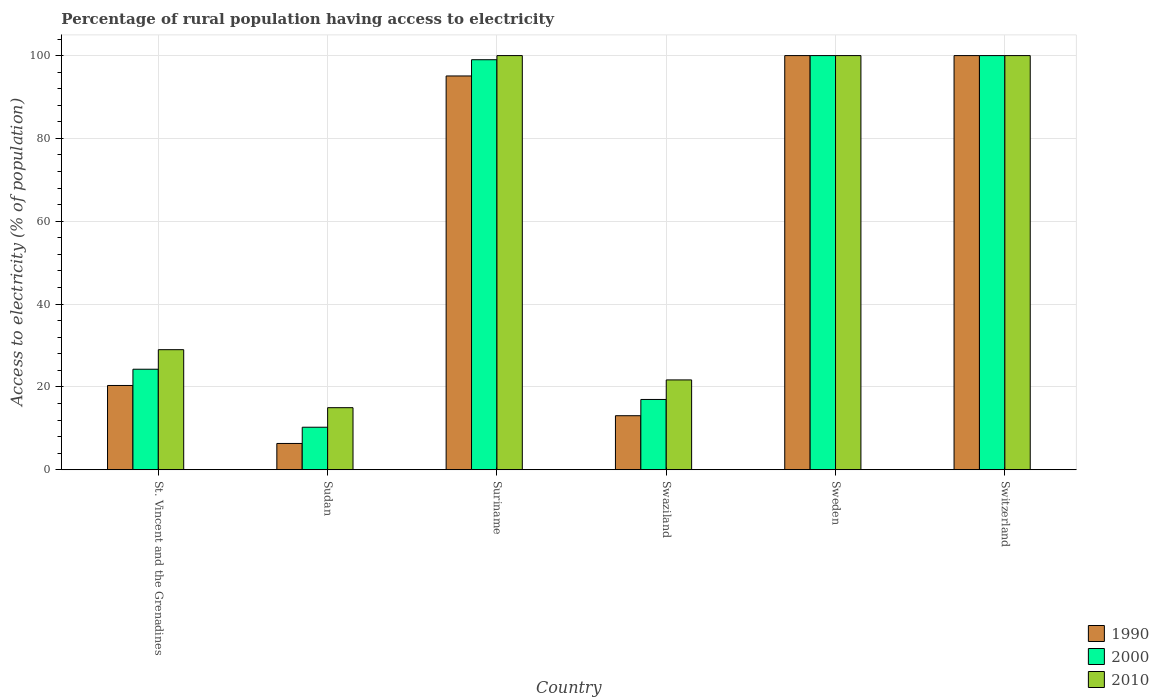How many groups of bars are there?
Offer a very short reply. 6. Are the number of bars per tick equal to the number of legend labels?
Ensure brevity in your answer.  Yes. How many bars are there on the 4th tick from the left?
Keep it short and to the point. 3. What is the label of the 1st group of bars from the left?
Offer a very short reply. St. Vincent and the Grenadines. What is the percentage of rural population having access to electricity in 2000 in Swaziland?
Your response must be concise. 16.98. In which country was the percentage of rural population having access to electricity in 2010 maximum?
Offer a very short reply. Suriname. In which country was the percentage of rural population having access to electricity in 1990 minimum?
Provide a succinct answer. Sudan. What is the total percentage of rural population having access to electricity in 2000 in the graph?
Offer a terse response. 350.54. What is the difference between the percentage of rural population having access to electricity in 1990 in Suriname and that in Swaziland?
Ensure brevity in your answer.  82.02. What is the average percentage of rural population having access to electricity in 1990 per country?
Offer a terse response. 55.81. What is the difference between the percentage of rural population having access to electricity of/in 1990 and percentage of rural population having access to electricity of/in 2010 in Sudan?
Provide a short and direct response. -8.64. In how many countries, is the percentage of rural population having access to electricity in 1990 greater than 4 %?
Ensure brevity in your answer.  6. What is the ratio of the percentage of rural population having access to electricity in 2000 in St. Vincent and the Grenadines to that in Switzerland?
Your answer should be very brief. 0.24. Is the percentage of rural population having access to electricity in 2010 in Swaziland less than that in Sweden?
Offer a terse response. Yes. Is the difference between the percentage of rural population having access to electricity in 1990 in Suriname and Swaziland greater than the difference between the percentage of rural population having access to electricity in 2010 in Suriname and Swaziland?
Your answer should be very brief. Yes. What is the difference between the highest and the lowest percentage of rural population having access to electricity in 2010?
Your answer should be compact. 85. Is the sum of the percentage of rural population having access to electricity in 1990 in Suriname and Swaziland greater than the maximum percentage of rural population having access to electricity in 2000 across all countries?
Give a very brief answer. Yes. What does the 1st bar from the right in St. Vincent and the Grenadines represents?
Your answer should be compact. 2010. How many bars are there?
Provide a short and direct response. 18. Are all the bars in the graph horizontal?
Make the answer very short. No. How many countries are there in the graph?
Ensure brevity in your answer.  6. Are the values on the major ticks of Y-axis written in scientific E-notation?
Make the answer very short. No. Does the graph contain any zero values?
Keep it short and to the point. No. Does the graph contain grids?
Your answer should be very brief. Yes. Where does the legend appear in the graph?
Provide a succinct answer. Bottom right. How are the legend labels stacked?
Keep it short and to the point. Vertical. What is the title of the graph?
Provide a short and direct response. Percentage of rural population having access to electricity. Does "1977" appear as one of the legend labels in the graph?
Keep it short and to the point. No. What is the label or title of the Y-axis?
Your answer should be very brief. Access to electricity (% of population). What is the Access to electricity (% of population) in 1990 in St. Vincent and the Grenadines?
Provide a succinct answer. 20.36. What is the Access to electricity (% of population) of 2000 in St. Vincent and the Grenadines?
Ensure brevity in your answer.  24.28. What is the Access to electricity (% of population) in 1990 in Sudan?
Keep it short and to the point. 6.36. What is the Access to electricity (% of population) in 2000 in Sudan?
Ensure brevity in your answer.  10.28. What is the Access to electricity (% of population) of 1990 in Suriname?
Keep it short and to the point. 95.08. What is the Access to electricity (% of population) of 2000 in Suriname?
Keep it short and to the point. 99. What is the Access to electricity (% of population) in 1990 in Swaziland?
Offer a very short reply. 13.06. What is the Access to electricity (% of population) in 2000 in Swaziland?
Ensure brevity in your answer.  16.98. What is the Access to electricity (% of population) in 2010 in Swaziland?
Offer a terse response. 21.7. What is the Access to electricity (% of population) in 2000 in Sweden?
Your answer should be very brief. 100. What is the Access to electricity (% of population) of 1990 in Switzerland?
Your answer should be compact. 100. Across all countries, what is the maximum Access to electricity (% of population) in 2000?
Ensure brevity in your answer.  100. Across all countries, what is the maximum Access to electricity (% of population) in 2010?
Provide a succinct answer. 100. Across all countries, what is the minimum Access to electricity (% of population) of 1990?
Offer a very short reply. 6.36. Across all countries, what is the minimum Access to electricity (% of population) of 2000?
Keep it short and to the point. 10.28. What is the total Access to electricity (% of population) in 1990 in the graph?
Your answer should be very brief. 334.86. What is the total Access to electricity (% of population) of 2000 in the graph?
Your answer should be very brief. 350.54. What is the total Access to electricity (% of population) in 2010 in the graph?
Your response must be concise. 365.7. What is the difference between the Access to electricity (% of population) of 2010 in St. Vincent and the Grenadines and that in Sudan?
Provide a short and direct response. 14. What is the difference between the Access to electricity (% of population) of 1990 in St. Vincent and the Grenadines and that in Suriname?
Provide a short and direct response. -74.72. What is the difference between the Access to electricity (% of population) in 2000 in St. Vincent and the Grenadines and that in Suriname?
Offer a very short reply. -74.72. What is the difference between the Access to electricity (% of population) in 2010 in St. Vincent and the Grenadines and that in Suriname?
Provide a short and direct response. -71. What is the difference between the Access to electricity (% of population) of 2010 in St. Vincent and the Grenadines and that in Swaziland?
Your answer should be very brief. 7.3. What is the difference between the Access to electricity (% of population) of 1990 in St. Vincent and the Grenadines and that in Sweden?
Your answer should be compact. -79.64. What is the difference between the Access to electricity (% of population) in 2000 in St. Vincent and the Grenadines and that in Sweden?
Your response must be concise. -75.72. What is the difference between the Access to electricity (% of population) in 2010 in St. Vincent and the Grenadines and that in Sweden?
Your answer should be compact. -71. What is the difference between the Access to electricity (% of population) in 1990 in St. Vincent and the Grenadines and that in Switzerland?
Your answer should be compact. -79.64. What is the difference between the Access to electricity (% of population) in 2000 in St. Vincent and the Grenadines and that in Switzerland?
Offer a terse response. -75.72. What is the difference between the Access to electricity (% of population) of 2010 in St. Vincent and the Grenadines and that in Switzerland?
Provide a succinct answer. -71. What is the difference between the Access to electricity (% of population) in 1990 in Sudan and that in Suriname?
Offer a terse response. -88.72. What is the difference between the Access to electricity (% of population) of 2000 in Sudan and that in Suriname?
Provide a short and direct response. -88.72. What is the difference between the Access to electricity (% of population) in 2010 in Sudan and that in Suriname?
Make the answer very short. -85. What is the difference between the Access to electricity (% of population) of 1990 in Sudan and that in Swaziland?
Give a very brief answer. -6.7. What is the difference between the Access to electricity (% of population) in 2000 in Sudan and that in Swaziland?
Ensure brevity in your answer.  -6.7. What is the difference between the Access to electricity (% of population) in 1990 in Sudan and that in Sweden?
Give a very brief answer. -93.64. What is the difference between the Access to electricity (% of population) in 2000 in Sudan and that in Sweden?
Provide a succinct answer. -89.72. What is the difference between the Access to electricity (% of population) of 2010 in Sudan and that in Sweden?
Make the answer very short. -85. What is the difference between the Access to electricity (% of population) of 1990 in Sudan and that in Switzerland?
Keep it short and to the point. -93.64. What is the difference between the Access to electricity (% of population) of 2000 in Sudan and that in Switzerland?
Provide a short and direct response. -89.72. What is the difference between the Access to electricity (% of population) in 2010 in Sudan and that in Switzerland?
Your response must be concise. -85. What is the difference between the Access to electricity (% of population) in 1990 in Suriname and that in Swaziland?
Offer a terse response. 82.02. What is the difference between the Access to electricity (% of population) of 2000 in Suriname and that in Swaziland?
Make the answer very short. 82.02. What is the difference between the Access to electricity (% of population) in 2010 in Suriname and that in Swaziland?
Your response must be concise. 78.3. What is the difference between the Access to electricity (% of population) in 1990 in Suriname and that in Sweden?
Your answer should be very brief. -4.92. What is the difference between the Access to electricity (% of population) in 1990 in Suriname and that in Switzerland?
Offer a terse response. -4.92. What is the difference between the Access to electricity (% of population) of 1990 in Swaziland and that in Sweden?
Ensure brevity in your answer.  -86.94. What is the difference between the Access to electricity (% of population) in 2000 in Swaziland and that in Sweden?
Make the answer very short. -83.02. What is the difference between the Access to electricity (% of population) in 2010 in Swaziland and that in Sweden?
Ensure brevity in your answer.  -78.3. What is the difference between the Access to electricity (% of population) in 1990 in Swaziland and that in Switzerland?
Provide a succinct answer. -86.94. What is the difference between the Access to electricity (% of population) in 2000 in Swaziland and that in Switzerland?
Give a very brief answer. -83.02. What is the difference between the Access to electricity (% of population) of 2010 in Swaziland and that in Switzerland?
Your answer should be compact. -78.3. What is the difference between the Access to electricity (% of population) of 1990 in St. Vincent and the Grenadines and the Access to electricity (% of population) of 2000 in Sudan?
Provide a short and direct response. 10.08. What is the difference between the Access to electricity (% of population) of 1990 in St. Vincent and the Grenadines and the Access to electricity (% of population) of 2010 in Sudan?
Ensure brevity in your answer.  5.36. What is the difference between the Access to electricity (% of population) in 2000 in St. Vincent and the Grenadines and the Access to electricity (% of population) in 2010 in Sudan?
Offer a terse response. 9.28. What is the difference between the Access to electricity (% of population) of 1990 in St. Vincent and the Grenadines and the Access to electricity (% of population) of 2000 in Suriname?
Your response must be concise. -78.64. What is the difference between the Access to electricity (% of population) in 1990 in St. Vincent and the Grenadines and the Access to electricity (% of population) in 2010 in Suriname?
Keep it short and to the point. -79.64. What is the difference between the Access to electricity (% of population) of 2000 in St. Vincent and the Grenadines and the Access to electricity (% of population) of 2010 in Suriname?
Give a very brief answer. -75.72. What is the difference between the Access to electricity (% of population) of 1990 in St. Vincent and the Grenadines and the Access to electricity (% of population) of 2000 in Swaziland?
Make the answer very short. 3.38. What is the difference between the Access to electricity (% of population) in 1990 in St. Vincent and the Grenadines and the Access to electricity (% of population) in 2010 in Swaziland?
Provide a short and direct response. -1.34. What is the difference between the Access to electricity (% of population) in 2000 in St. Vincent and the Grenadines and the Access to electricity (% of population) in 2010 in Swaziland?
Offer a terse response. 2.58. What is the difference between the Access to electricity (% of population) in 1990 in St. Vincent and the Grenadines and the Access to electricity (% of population) in 2000 in Sweden?
Offer a terse response. -79.64. What is the difference between the Access to electricity (% of population) in 1990 in St. Vincent and the Grenadines and the Access to electricity (% of population) in 2010 in Sweden?
Give a very brief answer. -79.64. What is the difference between the Access to electricity (% of population) of 2000 in St. Vincent and the Grenadines and the Access to electricity (% of population) of 2010 in Sweden?
Give a very brief answer. -75.72. What is the difference between the Access to electricity (% of population) of 1990 in St. Vincent and the Grenadines and the Access to electricity (% of population) of 2000 in Switzerland?
Give a very brief answer. -79.64. What is the difference between the Access to electricity (% of population) of 1990 in St. Vincent and the Grenadines and the Access to electricity (% of population) of 2010 in Switzerland?
Keep it short and to the point. -79.64. What is the difference between the Access to electricity (% of population) in 2000 in St. Vincent and the Grenadines and the Access to electricity (% of population) in 2010 in Switzerland?
Your answer should be compact. -75.72. What is the difference between the Access to electricity (% of population) in 1990 in Sudan and the Access to electricity (% of population) in 2000 in Suriname?
Provide a succinct answer. -92.64. What is the difference between the Access to electricity (% of population) in 1990 in Sudan and the Access to electricity (% of population) in 2010 in Suriname?
Keep it short and to the point. -93.64. What is the difference between the Access to electricity (% of population) in 2000 in Sudan and the Access to electricity (% of population) in 2010 in Suriname?
Keep it short and to the point. -89.72. What is the difference between the Access to electricity (% of population) of 1990 in Sudan and the Access to electricity (% of population) of 2000 in Swaziland?
Offer a very short reply. -10.62. What is the difference between the Access to electricity (% of population) of 1990 in Sudan and the Access to electricity (% of population) of 2010 in Swaziland?
Ensure brevity in your answer.  -15.34. What is the difference between the Access to electricity (% of population) in 2000 in Sudan and the Access to electricity (% of population) in 2010 in Swaziland?
Offer a terse response. -11.42. What is the difference between the Access to electricity (% of population) in 1990 in Sudan and the Access to electricity (% of population) in 2000 in Sweden?
Your response must be concise. -93.64. What is the difference between the Access to electricity (% of population) in 1990 in Sudan and the Access to electricity (% of population) in 2010 in Sweden?
Provide a succinct answer. -93.64. What is the difference between the Access to electricity (% of population) in 2000 in Sudan and the Access to electricity (% of population) in 2010 in Sweden?
Your response must be concise. -89.72. What is the difference between the Access to electricity (% of population) in 1990 in Sudan and the Access to electricity (% of population) in 2000 in Switzerland?
Provide a succinct answer. -93.64. What is the difference between the Access to electricity (% of population) of 1990 in Sudan and the Access to electricity (% of population) of 2010 in Switzerland?
Your response must be concise. -93.64. What is the difference between the Access to electricity (% of population) in 2000 in Sudan and the Access to electricity (% of population) in 2010 in Switzerland?
Your answer should be very brief. -89.72. What is the difference between the Access to electricity (% of population) of 1990 in Suriname and the Access to electricity (% of population) of 2000 in Swaziland?
Your answer should be compact. 78.1. What is the difference between the Access to electricity (% of population) in 1990 in Suriname and the Access to electricity (% of population) in 2010 in Swaziland?
Provide a succinct answer. 73.38. What is the difference between the Access to electricity (% of population) in 2000 in Suriname and the Access to electricity (% of population) in 2010 in Swaziland?
Make the answer very short. 77.3. What is the difference between the Access to electricity (% of population) in 1990 in Suriname and the Access to electricity (% of population) in 2000 in Sweden?
Your answer should be compact. -4.92. What is the difference between the Access to electricity (% of population) of 1990 in Suriname and the Access to electricity (% of population) of 2010 in Sweden?
Give a very brief answer. -4.92. What is the difference between the Access to electricity (% of population) in 2000 in Suriname and the Access to electricity (% of population) in 2010 in Sweden?
Make the answer very short. -1. What is the difference between the Access to electricity (% of population) of 1990 in Suriname and the Access to electricity (% of population) of 2000 in Switzerland?
Provide a succinct answer. -4.92. What is the difference between the Access to electricity (% of population) of 1990 in Suriname and the Access to electricity (% of population) of 2010 in Switzerland?
Provide a succinct answer. -4.92. What is the difference between the Access to electricity (% of population) in 2000 in Suriname and the Access to electricity (% of population) in 2010 in Switzerland?
Your answer should be compact. -1. What is the difference between the Access to electricity (% of population) of 1990 in Swaziland and the Access to electricity (% of population) of 2000 in Sweden?
Your answer should be very brief. -86.94. What is the difference between the Access to electricity (% of population) in 1990 in Swaziland and the Access to electricity (% of population) in 2010 in Sweden?
Ensure brevity in your answer.  -86.94. What is the difference between the Access to electricity (% of population) in 2000 in Swaziland and the Access to electricity (% of population) in 2010 in Sweden?
Give a very brief answer. -83.02. What is the difference between the Access to electricity (% of population) of 1990 in Swaziland and the Access to electricity (% of population) of 2000 in Switzerland?
Your answer should be very brief. -86.94. What is the difference between the Access to electricity (% of population) of 1990 in Swaziland and the Access to electricity (% of population) of 2010 in Switzerland?
Your response must be concise. -86.94. What is the difference between the Access to electricity (% of population) of 2000 in Swaziland and the Access to electricity (% of population) of 2010 in Switzerland?
Ensure brevity in your answer.  -83.02. What is the difference between the Access to electricity (% of population) of 1990 in Sweden and the Access to electricity (% of population) of 2000 in Switzerland?
Make the answer very short. 0. What is the difference between the Access to electricity (% of population) in 1990 in Sweden and the Access to electricity (% of population) in 2010 in Switzerland?
Your answer should be compact. 0. What is the average Access to electricity (% of population) of 1990 per country?
Offer a very short reply. 55.81. What is the average Access to electricity (% of population) in 2000 per country?
Your response must be concise. 58.42. What is the average Access to electricity (% of population) in 2010 per country?
Your answer should be compact. 60.95. What is the difference between the Access to electricity (% of population) in 1990 and Access to electricity (% of population) in 2000 in St. Vincent and the Grenadines?
Provide a succinct answer. -3.92. What is the difference between the Access to electricity (% of population) of 1990 and Access to electricity (% of population) of 2010 in St. Vincent and the Grenadines?
Offer a very short reply. -8.64. What is the difference between the Access to electricity (% of population) of 2000 and Access to electricity (% of population) of 2010 in St. Vincent and the Grenadines?
Your answer should be very brief. -4.72. What is the difference between the Access to electricity (% of population) of 1990 and Access to electricity (% of population) of 2000 in Sudan?
Your response must be concise. -3.92. What is the difference between the Access to electricity (% of population) in 1990 and Access to electricity (% of population) in 2010 in Sudan?
Keep it short and to the point. -8.64. What is the difference between the Access to electricity (% of population) in 2000 and Access to electricity (% of population) in 2010 in Sudan?
Offer a terse response. -4.72. What is the difference between the Access to electricity (% of population) in 1990 and Access to electricity (% of population) in 2000 in Suriname?
Ensure brevity in your answer.  -3.92. What is the difference between the Access to electricity (% of population) in 1990 and Access to electricity (% of population) in 2010 in Suriname?
Give a very brief answer. -4.92. What is the difference between the Access to electricity (% of population) in 2000 and Access to electricity (% of population) in 2010 in Suriname?
Keep it short and to the point. -1. What is the difference between the Access to electricity (% of population) in 1990 and Access to electricity (% of population) in 2000 in Swaziland?
Provide a succinct answer. -3.92. What is the difference between the Access to electricity (% of population) in 1990 and Access to electricity (% of population) in 2010 in Swaziland?
Your answer should be compact. -8.64. What is the difference between the Access to electricity (% of population) of 2000 and Access to electricity (% of population) of 2010 in Swaziland?
Your answer should be compact. -4.72. What is the difference between the Access to electricity (% of population) of 1990 and Access to electricity (% of population) of 2010 in Sweden?
Ensure brevity in your answer.  0. What is the difference between the Access to electricity (% of population) in 2000 and Access to electricity (% of population) in 2010 in Sweden?
Provide a succinct answer. 0. What is the difference between the Access to electricity (% of population) in 1990 and Access to electricity (% of population) in 2000 in Switzerland?
Your response must be concise. 0. What is the ratio of the Access to electricity (% of population) in 1990 in St. Vincent and the Grenadines to that in Sudan?
Ensure brevity in your answer.  3.2. What is the ratio of the Access to electricity (% of population) in 2000 in St. Vincent and the Grenadines to that in Sudan?
Provide a succinct answer. 2.36. What is the ratio of the Access to electricity (% of population) of 2010 in St. Vincent and the Grenadines to that in Sudan?
Ensure brevity in your answer.  1.93. What is the ratio of the Access to electricity (% of population) of 1990 in St. Vincent and the Grenadines to that in Suriname?
Provide a succinct answer. 0.21. What is the ratio of the Access to electricity (% of population) of 2000 in St. Vincent and the Grenadines to that in Suriname?
Offer a terse response. 0.25. What is the ratio of the Access to electricity (% of population) of 2010 in St. Vincent and the Grenadines to that in Suriname?
Provide a short and direct response. 0.29. What is the ratio of the Access to electricity (% of population) in 1990 in St. Vincent and the Grenadines to that in Swaziland?
Provide a short and direct response. 1.56. What is the ratio of the Access to electricity (% of population) in 2000 in St. Vincent and the Grenadines to that in Swaziland?
Provide a succinct answer. 1.43. What is the ratio of the Access to electricity (% of population) of 2010 in St. Vincent and the Grenadines to that in Swaziland?
Provide a short and direct response. 1.34. What is the ratio of the Access to electricity (% of population) of 1990 in St. Vincent and the Grenadines to that in Sweden?
Provide a succinct answer. 0.2. What is the ratio of the Access to electricity (% of population) of 2000 in St. Vincent and the Grenadines to that in Sweden?
Ensure brevity in your answer.  0.24. What is the ratio of the Access to electricity (% of population) of 2010 in St. Vincent and the Grenadines to that in Sweden?
Keep it short and to the point. 0.29. What is the ratio of the Access to electricity (% of population) in 1990 in St. Vincent and the Grenadines to that in Switzerland?
Provide a succinct answer. 0.2. What is the ratio of the Access to electricity (% of population) in 2000 in St. Vincent and the Grenadines to that in Switzerland?
Your answer should be very brief. 0.24. What is the ratio of the Access to electricity (% of population) in 2010 in St. Vincent and the Grenadines to that in Switzerland?
Offer a terse response. 0.29. What is the ratio of the Access to electricity (% of population) of 1990 in Sudan to that in Suriname?
Provide a short and direct response. 0.07. What is the ratio of the Access to electricity (% of population) of 2000 in Sudan to that in Suriname?
Offer a very short reply. 0.1. What is the ratio of the Access to electricity (% of population) in 1990 in Sudan to that in Swaziland?
Keep it short and to the point. 0.49. What is the ratio of the Access to electricity (% of population) of 2000 in Sudan to that in Swaziland?
Give a very brief answer. 0.61. What is the ratio of the Access to electricity (% of population) of 2010 in Sudan to that in Swaziland?
Ensure brevity in your answer.  0.69. What is the ratio of the Access to electricity (% of population) in 1990 in Sudan to that in Sweden?
Make the answer very short. 0.06. What is the ratio of the Access to electricity (% of population) of 2000 in Sudan to that in Sweden?
Offer a very short reply. 0.1. What is the ratio of the Access to electricity (% of population) of 1990 in Sudan to that in Switzerland?
Your answer should be very brief. 0.06. What is the ratio of the Access to electricity (% of population) in 2000 in Sudan to that in Switzerland?
Your response must be concise. 0.1. What is the ratio of the Access to electricity (% of population) of 1990 in Suriname to that in Swaziland?
Offer a terse response. 7.28. What is the ratio of the Access to electricity (% of population) of 2000 in Suriname to that in Swaziland?
Provide a succinct answer. 5.83. What is the ratio of the Access to electricity (% of population) of 2010 in Suriname to that in Swaziland?
Provide a short and direct response. 4.61. What is the ratio of the Access to electricity (% of population) of 1990 in Suriname to that in Sweden?
Give a very brief answer. 0.95. What is the ratio of the Access to electricity (% of population) in 2010 in Suriname to that in Sweden?
Your answer should be very brief. 1. What is the ratio of the Access to electricity (% of population) of 1990 in Suriname to that in Switzerland?
Your answer should be very brief. 0.95. What is the ratio of the Access to electricity (% of population) in 2000 in Suriname to that in Switzerland?
Ensure brevity in your answer.  0.99. What is the ratio of the Access to electricity (% of population) of 1990 in Swaziland to that in Sweden?
Your answer should be very brief. 0.13. What is the ratio of the Access to electricity (% of population) in 2000 in Swaziland to that in Sweden?
Provide a short and direct response. 0.17. What is the ratio of the Access to electricity (% of population) in 2010 in Swaziland to that in Sweden?
Keep it short and to the point. 0.22. What is the ratio of the Access to electricity (% of population) of 1990 in Swaziland to that in Switzerland?
Provide a succinct answer. 0.13. What is the ratio of the Access to electricity (% of population) of 2000 in Swaziland to that in Switzerland?
Provide a short and direct response. 0.17. What is the ratio of the Access to electricity (% of population) in 2010 in Swaziland to that in Switzerland?
Provide a succinct answer. 0.22. What is the difference between the highest and the second highest Access to electricity (% of population) of 2010?
Offer a terse response. 0. What is the difference between the highest and the lowest Access to electricity (% of population) in 1990?
Offer a very short reply. 93.64. What is the difference between the highest and the lowest Access to electricity (% of population) of 2000?
Offer a very short reply. 89.72. 